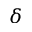<formula> <loc_0><loc_0><loc_500><loc_500>\delta</formula> 